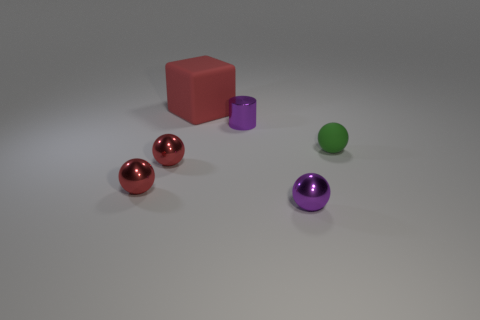What is the size of the matte sphere?
Your response must be concise. Small. The tiny matte sphere on the right side of the purple metal thing that is to the left of the tiny metallic ball right of the tiny purple cylinder is what color?
Offer a terse response. Green. There is a metallic sphere that is right of the large red block; is it the same color as the small shiny cylinder?
Offer a very short reply. Yes. How many things are both on the left side of the green rubber object and in front of the large red rubber block?
Provide a short and direct response. 4. There is a object that is behind the small thing that is behind the small green matte sphere; how many red cubes are in front of it?
Your answer should be very brief. 0. What color is the small object that is on the right side of the purple metal object in front of the tiny matte ball?
Offer a terse response. Green. How many other things are there of the same material as the large red cube?
Offer a terse response. 1. How many things are in front of the object that is right of the tiny purple metallic ball?
Ensure brevity in your answer.  3. Is there anything else that has the same shape as the green matte object?
Provide a succinct answer. Yes. Is the color of the small metallic ball that is on the right side of the tiny purple metallic cylinder the same as the tiny object behind the matte sphere?
Ensure brevity in your answer.  Yes. 